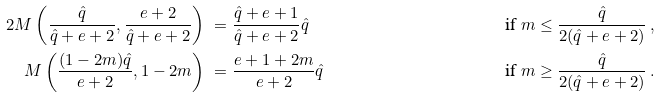Convert formula to latex. <formula><loc_0><loc_0><loc_500><loc_500>2 M \left ( \frac { \hat { q } } { \hat { q } + e + 2 } , \frac { e + 2 } { \hat { q } + e + 2 } \right ) & \ = \frac { \hat { q } + e + 1 } { \hat { q } + e + 2 } \hat { q } & \quad & \text { if } m \leq \frac { \hat { q } } { 2 ( \hat { q } + e + 2 ) } \, , \\ M \left ( \frac { ( 1 - 2 m ) \hat { q } } { e + 2 } , 1 - 2 m \right ) & \ = \frac { e + 1 + 2 m } { e + 2 } \hat { q } & & \text { if } m \geq \frac { \hat { q } } { 2 ( \hat { q } + e + 2 ) } \, .</formula> 